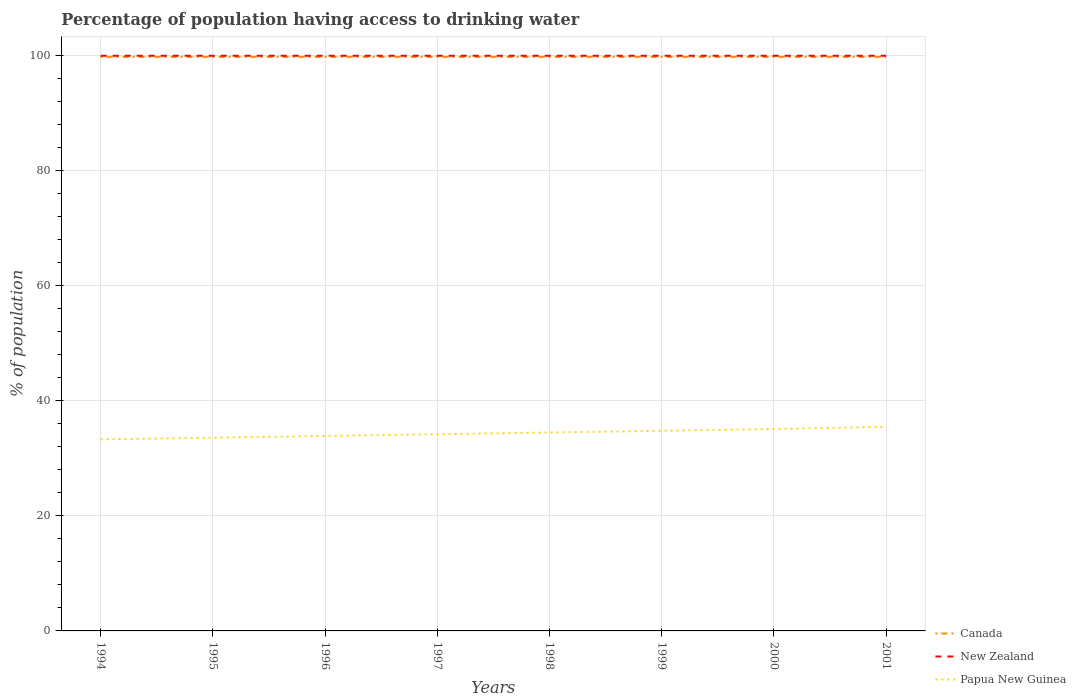How many different coloured lines are there?
Offer a terse response. 3. Is the number of lines equal to the number of legend labels?
Your answer should be compact. Yes. Across all years, what is the maximum percentage of population having access to drinking water in Canada?
Ensure brevity in your answer.  99.8. In which year was the percentage of population having access to drinking water in Canada maximum?
Your answer should be compact. 1994. What is the difference between the highest and the second highest percentage of population having access to drinking water in Papua New Guinea?
Make the answer very short. 2.2. What is the difference between the highest and the lowest percentage of population having access to drinking water in Canada?
Provide a succinct answer. 0. How many years are there in the graph?
Your answer should be compact. 8. Does the graph contain any zero values?
Keep it short and to the point. No. Does the graph contain grids?
Give a very brief answer. Yes. Where does the legend appear in the graph?
Your answer should be compact. Bottom right. How are the legend labels stacked?
Your answer should be compact. Vertical. What is the title of the graph?
Offer a terse response. Percentage of population having access to drinking water. What is the label or title of the X-axis?
Offer a terse response. Years. What is the label or title of the Y-axis?
Ensure brevity in your answer.  % of population. What is the % of population of Canada in 1994?
Offer a very short reply. 99.8. What is the % of population in New Zealand in 1994?
Your answer should be compact. 100. What is the % of population in Papua New Guinea in 1994?
Ensure brevity in your answer.  33.3. What is the % of population of Canada in 1995?
Provide a succinct answer. 99.8. What is the % of population of New Zealand in 1995?
Provide a short and direct response. 100. What is the % of population in Papua New Guinea in 1995?
Your response must be concise. 33.6. What is the % of population in Canada in 1996?
Offer a terse response. 99.8. What is the % of population of Papua New Guinea in 1996?
Offer a very short reply. 33.9. What is the % of population of Canada in 1997?
Provide a short and direct response. 99.8. What is the % of population of New Zealand in 1997?
Ensure brevity in your answer.  100. What is the % of population in Papua New Guinea in 1997?
Your answer should be very brief. 34.2. What is the % of population in Canada in 1998?
Your answer should be very brief. 99.8. What is the % of population in New Zealand in 1998?
Your answer should be very brief. 100. What is the % of population of Papua New Guinea in 1998?
Provide a short and direct response. 34.5. What is the % of population in Canada in 1999?
Your response must be concise. 99.8. What is the % of population in New Zealand in 1999?
Make the answer very short. 100. What is the % of population in Papua New Guinea in 1999?
Make the answer very short. 34.8. What is the % of population in Canada in 2000?
Ensure brevity in your answer.  99.8. What is the % of population in Papua New Guinea in 2000?
Provide a succinct answer. 35.1. What is the % of population in Canada in 2001?
Your answer should be compact. 99.8. What is the % of population in Papua New Guinea in 2001?
Your answer should be very brief. 35.5. Across all years, what is the maximum % of population of Canada?
Give a very brief answer. 99.8. Across all years, what is the maximum % of population of New Zealand?
Provide a short and direct response. 100. Across all years, what is the maximum % of population in Papua New Guinea?
Ensure brevity in your answer.  35.5. Across all years, what is the minimum % of population in Canada?
Your answer should be very brief. 99.8. Across all years, what is the minimum % of population in Papua New Guinea?
Your answer should be compact. 33.3. What is the total % of population of Canada in the graph?
Make the answer very short. 798.4. What is the total % of population of New Zealand in the graph?
Provide a succinct answer. 800. What is the total % of population in Papua New Guinea in the graph?
Your response must be concise. 274.9. What is the difference between the % of population of Canada in 1994 and that in 1995?
Provide a succinct answer. 0. What is the difference between the % of population in Canada in 1994 and that in 1996?
Ensure brevity in your answer.  0. What is the difference between the % of population in Canada in 1994 and that in 1997?
Ensure brevity in your answer.  0. What is the difference between the % of population in Papua New Guinea in 1994 and that in 1998?
Offer a very short reply. -1.2. What is the difference between the % of population in Canada in 1994 and that in 2000?
Offer a terse response. 0. What is the difference between the % of population of Papua New Guinea in 1994 and that in 2000?
Provide a succinct answer. -1.8. What is the difference between the % of population in Canada in 1994 and that in 2001?
Your answer should be very brief. 0. What is the difference between the % of population of New Zealand in 1994 and that in 2001?
Keep it short and to the point. 0. What is the difference between the % of population in Papua New Guinea in 1994 and that in 2001?
Offer a terse response. -2.2. What is the difference between the % of population in New Zealand in 1995 and that in 1997?
Provide a succinct answer. 0. What is the difference between the % of population of Papua New Guinea in 1995 and that in 1997?
Provide a succinct answer. -0.6. What is the difference between the % of population of Canada in 1995 and that in 1999?
Make the answer very short. 0. What is the difference between the % of population of Papua New Guinea in 1995 and that in 1999?
Provide a succinct answer. -1.2. What is the difference between the % of population in Canada in 1995 and that in 2000?
Your answer should be very brief. 0. What is the difference between the % of population in New Zealand in 1995 and that in 2000?
Offer a very short reply. 0. What is the difference between the % of population in Papua New Guinea in 1995 and that in 2000?
Your answer should be very brief. -1.5. What is the difference between the % of population of New Zealand in 1995 and that in 2001?
Your answer should be compact. 0. What is the difference between the % of population in Papua New Guinea in 1995 and that in 2001?
Offer a terse response. -1.9. What is the difference between the % of population of New Zealand in 1996 and that in 1997?
Make the answer very short. 0. What is the difference between the % of population of Papua New Guinea in 1996 and that in 1997?
Your answer should be compact. -0.3. What is the difference between the % of population of New Zealand in 1996 and that in 1998?
Offer a very short reply. 0. What is the difference between the % of population in Papua New Guinea in 1996 and that in 1998?
Your answer should be very brief. -0.6. What is the difference between the % of population in Canada in 1996 and that in 1999?
Provide a succinct answer. 0. What is the difference between the % of population of Canada in 1996 and that in 2000?
Give a very brief answer. 0. What is the difference between the % of population in New Zealand in 1996 and that in 2000?
Your answer should be compact. 0. What is the difference between the % of population in Canada in 1996 and that in 2001?
Offer a very short reply. 0. What is the difference between the % of population in New Zealand in 1996 and that in 2001?
Provide a succinct answer. 0. What is the difference between the % of population in Papua New Guinea in 1997 and that in 1998?
Your answer should be very brief. -0.3. What is the difference between the % of population in Canada in 1997 and that in 1999?
Provide a succinct answer. 0. What is the difference between the % of population in New Zealand in 1997 and that in 1999?
Your response must be concise. 0. What is the difference between the % of population of Papua New Guinea in 1997 and that in 1999?
Offer a very short reply. -0.6. What is the difference between the % of population in New Zealand in 1997 and that in 2000?
Make the answer very short. 0. What is the difference between the % of population in Papua New Guinea in 1997 and that in 2000?
Your answer should be very brief. -0.9. What is the difference between the % of population in Canada in 1998 and that in 1999?
Provide a short and direct response. 0. What is the difference between the % of population of Papua New Guinea in 1998 and that in 1999?
Make the answer very short. -0.3. What is the difference between the % of population of Canada in 1998 and that in 2000?
Your answer should be compact. 0. What is the difference between the % of population of Papua New Guinea in 1998 and that in 2000?
Give a very brief answer. -0.6. What is the difference between the % of population in Canada in 1998 and that in 2001?
Offer a very short reply. 0. What is the difference between the % of population in Papua New Guinea in 1999 and that in 2000?
Offer a terse response. -0.3. What is the difference between the % of population of New Zealand in 2000 and that in 2001?
Keep it short and to the point. 0. What is the difference between the % of population of Papua New Guinea in 2000 and that in 2001?
Make the answer very short. -0.4. What is the difference between the % of population of Canada in 1994 and the % of population of New Zealand in 1995?
Your response must be concise. -0.2. What is the difference between the % of population in Canada in 1994 and the % of population in Papua New Guinea in 1995?
Keep it short and to the point. 66.2. What is the difference between the % of population of New Zealand in 1994 and the % of population of Papua New Guinea in 1995?
Offer a very short reply. 66.4. What is the difference between the % of population in Canada in 1994 and the % of population in Papua New Guinea in 1996?
Make the answer very short. 65.9. What is the difference between the % of population in New Zealand in 1994 and the % of population in Papua New Guinea in 1996?
Provide a succinct answer. 66.1. What is the difference between the % of population of Canada in 1994 and the % of population of Papua New Guinea in 1997?
Your response must be concise. 65.6. What is the difference between the % of population in New Zealand in 1994 and the % of population in Papua New Guinea in 1997?
Your response must be concise. 65.8. What is the difference between the % of population of Canada in 1994 and the % of population of New Zealand in 1998?
Provide a succinct answer. -0.2. What is the difference between the % of population of Canada in 1994 and the % of population of Papua New Guinea in 1998?
Offer a terse response. 65.3. What is the difference between the % of population of New Zealand in 1994 and the % of population of Papua New Guinea in 1998?
Keep it short and to the point. 65.5. What is the difference between the % of population in Canada in 1994 and the % of population in New Zealand in 1999?
Provide a short and direct response. -0.2. What is the difference between the % of population in Canada in 1994 and the % of population in Papua New Guinea in 1999?
Provide a short and direct response. 65. What is the difference between the % of population of New Zealand in 1994 and the % of population of Papua New Guinea in 1999?
Provide a succinct answer. 65.2. What is the difference between the % of population of Canada in 1994 and the % of population of New Zealand in 2000?
Keep it short and to the point. -0.2. What is the difference between the % of population of Canada in 1994 and the % of population of Papua New Guinea in 2000?
Provide a short and direct response. 64.7. What is the difference between the % of population in New Zealand in 1994 and the % of population in Papua New Guinea in 2000?
Provide a succinct answer. 64.9. What is the difference between the % of population in Canada in 1994 and the % of population in Papua New Guinea in 2001?
Offer a very short reply. 64.3. What is the difference between the % of population of New Zealand in 1994 and the % of population of Papua New Guinea in 2001?
Offer a terse response. 64.5. What is the difference between the % of population of Canada in 1995 and the % of population of Papua New Guinea in 1996?
Provide a succinct answer. 65.9. What is the difference between the % of population in New Zealand in 1995 and the % of population in Papua New Guinea in 1996?
Offer a terse response. 66.1. What is the difference between the % of population in Canada in 1995 and the % of population in Papua New Guinea in 1997?
Your answer should be very brief. 65.6. What is the difference between the % of population of New Zealand in 1995 and the % of population of Papua New Guinea in 1997?
Provide a short and direct response. 65.8. What is the difference between the % of population in Canada in 1995 and the % of population in Papua New Guinea in 1998?
Your answer should be very brief. 65.3. What is the difference between the % of population of New Zealand in 1995 and the % of population of Papua New Guinea in 1998?
Offer a very short reply. 65.5. What is the difference between the % of population of Canada in 1995 and the % of population of Papua New Guinea in 1999?
Offer a terse response. 65. What is the difference between the % of population in New Zealand in 1995 and the % of population in Papua New Guinea in 1999?
Provide a short and direct response. 65.2. What is the difference between the % of population in Canada in 1995 and the % of population in New Zealand in 2000?
Provide a short and direct response. -0.2. What is the difference between the % of population of Canada in 1995 and the % of population of Papua New Guinea in 2000?
Your answer should be compact. 64.7. What is the difference between the % of population of New Zealand in 1995 and the % of population of Papua New Guinea in 2000?
Provide a short and direct response. 64.9. What is the difference between the % of population in Canada in 1995 and the % of population in New Zealand in 2001?
Your answer should be very brief. -0.2. What is the difference between the % of population in Canada in 1995 and the % of population in Papua New Guinea in 2001?
Offer a terse response. 64.3. What is the difference between the % of population of New Zealand in 1995 and the % of population of Papua New Guinea in 2001?
Give a very brief answer. 64.5. What is the difference between the % of population in Canada in 1996 and the % of population in Papua New Guinea in 1997?
Your answer should be compact. 65.6. What is the difference between the % of population of New Zealand in 1996 and the % of population of Papua New Guinea in 1997?
Provide a short and direct response. 65.8. What is the difference between the % of population of Canada in 1996 and the % of population of Papua New Guinea in 1998?
Provide a succinct answer. 65.3. What is the difference between the % of population of New Zealand in 1996 and the % of population of Papua New Guinea in 1998?
Provide a short and direct response. 65.5. What is the difference between the % of population of New Zealand in 1996 and the % of population of Papua New Guinea in 1999?
Provide a short and direct response. 65.2. What is the difference between the % of population of Canada in 1996 and the % of population of Papua New Guinea in 2000?
Give a very brief answer. 64.7. What is the difference between the % of population of New Zealand in 1996 and the % of population of Papua New Guinea in 2000?
Provide a succinct answer. 64.9. What is the difference between the % of population in Canada in 1996 and the % of population in Papua New Guinea in 2001?
Offer a terse response. 64.3. What is the difference between the % of population of New Zealand in 1996 and the % of population of Papua New Guinea in 2001?
Your response must be concise. 64.5. What is the difference between the % of population of Canada in 1997 and the % of population of New Zealand in 1998?
Your response must be concise. -0.2. What is the difference between the % of population in Canada in 1997 and the % of population in Papua New Guinea in 1998?
Your answer should be compact. 65.3. What is the difference between the % of population of New Zealand in 1997 and the % of population of Papua New Guinea in 1998?
Your response must be concise. 65.5. What is the difference between the % of population of Canada in 1997 and the % of population of New Zealand in 1999?
Keep it short and to the point. -0.2. What is the difference between the % of population in Canada in 1997 and the % of population in Papua New Guinea in 1999?
Your response must be concise. 65. What is the difference between the % of population in New Zealand in 1997 and the % of population in Papua New Guinea in 1999?
Keep it short and to the point. 65.2. What is the difference between the % of population in Canada in 1997 and the % of population in Papua New Guinea in 2000?
Make the answer very short. 64.7. What is the difference between the % of population of New Zealand in 1997 and the % of population of Papua New Guinea in 2000?
Keep it short and to the point. 64.9. What is the difference between the % of population in Canada in 1997 and the % of population in Papua New Guinea in 2001?
Offer a terse response. 64.3. What is the difference between the % of population of New Zealand in 1997 and the % of population of Papua New Guinea in 2001?
Ensure brevity in your answer.  64.5. What is the difference between the % of population in Canada in 1998 and the % of population in New Zealand in 1999?
Offer a very short reply. -0.2. What is the difference between the % of population of Canada in 1998 and the % of population of Papua New Guinea in 1999?
Offer a very short reply. 65. What is the difference between the % of population of New Zealand in 1998 and the % of population of Papua New Guinea in 1999?
Ensure brevity in your answer.  65.2. What is the difference between the % of population of Canada in 1998 and the % of population of New Zealand in 2000?
Ensure brevity in your answer.  -0.2. What is the difference between the % of population in Canada in 1998 and the % of population in Papua New Guinea in 2000?
Provide a short and direct response. 64.7. What is the difference between the % of population in New Zealand in 1998 and the % of population in Papua New Guinea in 2000?
Offer a terse response. 64.9. What is the difference between the % of population of Canada in 1998 and the % of population of Papua New Guinea in 2001?
Give a very brief answer. 64.3. What is the difference between the % of population in New Zealand in 1998 and the % of population in Papua New Guinea in 2001?
Keep it short and to the point. 64.5. What is the difference between the % of population of Canada in 1999 and the % of population of New Zealand in 2000?
Make the answer very short. -0.2. What is the difference between the % of population of Canada in 1999 and the % of population of Papua New Guinea in 2000?
Your answer should be very brief. 64.7. What is the difference between the % of population of New Zealand in 1999 and the % of population of Papua New Guinea in 2000?
Make the answer very short. 64.9. What is the difference between the % of population of Canada in 1999 and the % of population of New Zealand in 2001?
Give a very brief answer. -0.2. What is the difference between the % of population in Canada in 1999 and the % of population in Papua New Guinea in 2001?
Offer a very short reply. 64.3. What is the difference between the % of population in New Zealand in 1999 and the % of population in Papua New Guinea in 2001?
Your response must be concise. 64.5. What is the difference between the % of population in Canada in 2000 and the % of population in New Zealand in 2001?
Your answer should be compact. -0.2. What is the difference between the % of population in Canada in 2000 and the % of population in Papua New Guinea in 2001?
Make the answer very short. 64.3. What is the difference between the % of population in New Zealand in 2000 and the % of population in Papua New Guinea in 2001?
Ensure brevity in your answer.  64.5. What is the average % of population of Canada per year?
Your response must be concise. 99.8. What is the average % of population of New Zealand per year?
Your answer should be very brief. 100. What is the average % of population of Papua New Guinea per year?
Your answer should be compact. 34.36. In the year 1994, what is the difference between the % of population in Canada and % of population in New Zealand?
Your response must be concise. -0.2. In the year 1994, what is the difference between the % of population of Canada and % of population of Papua New Guinea?
Your answer should be compact. 66.5. In the year 1994, what is the difference between the % of population in New Zealand and % of population in Papua New Guinea?
Provide a short and direct response. 66.7. In the year 1995, what is the difference between the % of population of Canada and % of population of Papua New Guinea?
Offer a very short reply. 66.2. In the year 1995, what is the difference between the % of population of New Zealand and % of population of Papua New Guinea?
Your answer should be compact. 66.4. In the year 1996, what is the difference between the % of population of Canada and % of population of New Zealand?
Give a very brief answer. -0.2. In the year 1996, what is the difference between the % of population of Canada and % of population of Papua New Guinea?
Make the answer very short. 65.9. In the year 1996, what is the difference between the % of population of New Zealand and % of population of Papua New Guinea?
Your response must be concise. 66.1. In the year 1997, what is the difference between the % of population of Canada and % of population of New Zealand?
Provide a short and direct response. -0.2. In the year 1997, what is the difference between the % of population in Canada and % of population in Papua New Guinea?
Your answer should be compact. 65.6. In the year 1997, what is the difference between the % of population in New Zealand and % of population in Papua New Guinea?
Your answer should be compact. 65.8. In the year 1998, what is the difference between the % of population in Canada and % of population in New Zealand?
Provide a short and direct response. -0.2. In the year 1998, what is the difference between the % of population in Canada and % of population in Papua New Guinea?
Ensure brevity in your answer.  65.3. In the year 1998, what is the difference between the % of population in New Zealand and % of population in Papua New Guinea?
Provide a short and direct response. 65.5. In the year 1999, what is the difference between the % of population of Canada and % of population of New Zealand?
Give a very brief answer. -0.2. In the year 1999, what is the difference between the % of population of Canada and % of population of Papua New Guinea?
Your answer should be compact. 65. In the year 1999, what is the difference between the % of population in New Zealand and % of population in Papua New Guinea?
Your answer should be very brief. 65.2. In the year 2000, what is the difference between the % of population of Canada and % of population of New Zealand?
Offer a terse response. -0.2. In the year 2000, what is the difference between the % of population in Canada and % of population in Papua New Guinea?
Ensure brevity in your answer.  64.7. In the year 2000, what is the difference between the % of population of New Zealand and % of population of Papua New Guinea?
Give a very brief answer. 64.9. In the year 2001, what is the difference between the % of population of Canada and % of population of Papua New Guinea?
Ensure brevity in your answer.  64.3. In the year 2001, what is the difference between the % of population of New Zealand and % of population of Papua New Guinea?
Provide a succinct answer. 64.5. What is the ratio of the % of population in New Zealand in 1994 to that in 1995?
Provide a succinct answer. 1. What is the ratio of the % of population of Papua New Guinea in 1994 to that in 1995?
Make the answer very short. 0.99. What is the ratio of the % of population of Canada in 1994 to that in 1996?
Provide a succinct answer. 1. What is the ratio of the % of population of Papua New Guinea in 1994 to that in 1996?
Make the answer very short. 0.98. What is the ratio of the % of population in Canada in 1994 to that in 1997?
Your answer should be very brief. 1. What is the ratio of the % of population in Papua New Guinea in 1994 to that in 1997?
Your answer should be compact. 0.97. What is the ratio of the % of population in Canada in 1994 to that in 1998?
Your answer should be very brief. 1. What is the ratio of the % of population in New Zealand in 1994 to that in 1998?
Offer a very short reply. 1. What is the ratio of the % of population in Papua New Guinea in 1994 to that in 1998?
Offer a very short reply. 0.97. What is the ratio of the % of population of Papua New Guinea in 1994 to that in 1999?
Make the answer very short. 0.96. What is the ratio of the % of population of Canada in 1994 to that in 2000?
Ensure brevity in your answer.  1. What is the ratio of the % of population of New Zealand in 1994 to that in 2000?
Provide a succinct answer. 1. What is the ratio of the % of population of Papua New Guinea in 1994 to that in 2000?
Offer a very short reply. 0.95. What is the ratio of the % of population of Canada in 1994 to that in 2001?
Your answer should be compact. 1. What is the ratio of the % of population of Papua New Guinea in 1994 to that in 2001?
Make the answer very short. 0.94. What is the ratio of the % of population of Canada in 1995 to that in 1996?
Your answer should be compact. 1. What is the ratio of the % of population of Papua New Guinea in 1995 to that in 1996?
Keep it short and to the point. 0.99. What is the ratio of the % of population of Papua New Guinea in 1995 to that in 1997?
Ensure brevity in your answer.  0.98. What is the ratio of the % of population in Canada in 1995 to that in 1998?
Provide a short and direct response. 1. What is the ratio of the % of population in New Zealand in 1995 to that in 1998?
Give a very brief answer. 1. What is the ratio of the % of population in Papua New Guinea in 1995 to that in 1998?
Offer a very short reply. 0.97. What is the ratio of the % of population in New Zealand in 1995 to that in 1999?
Ensure brevity in your answer.  1. What is the ratio of the % of population in Papua New Guinea in 1995 to that in 1999?
Your response must be concise. 0.97. What is the ratio of the % of population in Canada in 1995 to that in 2000?
Your answer should be very brief. 1. What is the ratio of the % of population in Papua New Guinea in 1995 to that in 2000?
Give a very brief answer. 0.96. What is the ratio of the % of population in Papua New Guinea in 1995 to that in 2001?
Provide a succinct answer. 0.95. What is the ratio of the % of population in New Zealand in 1996 to that in 1997?
Ensure brevity in your answer.  1. What is the ratio of the % of population in Papua New Guinea in 1996 to that in 1997?
Your response must be concise. 0.99. What is the ratio of the % of population of New Zealand in 1996 to that in 1998?
Your answer should be very brief. 1. What is the ratio of the % of population in Papua New Guinea in 1996 to that in 1998?
Keep it short and to the point. 0.98. What is the ratio of the % of population of Canada in 1996 to that in 1999?
Offer a terse response. 1. What is the ratio of the % of population in New Zealand in 1996 to that in 1999?
Provide a short and direct response. 1. What is the ratio of the % of population of Papua New Guinea in 1996 to that in 1999?
Keep it short and to the point. 0.97. What is the ratio of the % of population in Canada in 1996 to that in 2000?
Your answer should be very brief. 1. What is the ratio of the % of population in Papua New Guinea in 1996 to that in 2000?
Offer a very short reply. 0.97. What is the ratio of the % of population of Canada in 1996 to that in 2001?
Provide a succinct answer. 1. What is the ratio of the % of population of Papua New Guinea in 1996 to that in 2001?
Make the answer very short. 0.95. What is the ratio of the % of population of New Zealand in 1997 to that in 1998?
Your response must be concise. 1. What is the ratio of the % of population in Canada in 1997 to that in 1999?
Your answer should be compact. 1. What is the ratio of the % of population of Papua New Guinea in 1997 to that in 1999?
Offer a very short reply. 0.98. What is the ratio of the % of population in Papua New Guinea in 1997 to that in 2000?
Keep it short and to the point. 0.97. What is the ratio of the % of population in Canada in 1997 to that in 2001?
Offer a very short reply. 1. What is the ratio of the % of population in New Zealand in 1997 to that in 2001?
Offer a terse response. 1. What is the ratio of the % of population in Papua New Guinea in 1997 to that in 2001?
Keep it short and to the point. 0.96. What is the ratio of the % of population of New Zealand in 1998 to that in 1999?
Your answer should be very brief. 1. What is the ratio of the % of population in New Zealand in 1998 to that in 2000?
Offer a terse response. 1. What is the ratio of the % of population of Papua New Guinea in 1998 to that in 2000?
Ensure brevity in your answer.  0.98. What is the ratio of the % of population in Canada in 1998 to that in 2001?
Your answer should be compact. 1. What is the ratio of the % of population of Papua New Guinea in 1998 to that in 2001?
Provide a succinct answer. 0.97. What is the ratio of the % of population of Canada in 1999 to that in 2000?
Provide a short and direct response. 1. What is the ratio of the % of population of New Zealand in 1999 to that in 2000?
Your response must be concise. 1. What is the ratio of the % of population of Papua New Guinea in 1999 to that in 2001?
Your answer should be very brief. 0.98. What is the ratio of the % of population in New Zealand in 2000 to that in 2001?
Offer a terse response. 1. What is the ratio of the % of population of Papua New Guinea in 2000 to that in 2001?
Your answer should be compact. 0.99. What is the difference between the highest and the second highest % of population of Canada?
Provide a short and direct response. 0. What is the difference between the highest and the lowest % of population of New Zealand?
Ensure brevity in your answer.  0. What is the difference between the highest and the lowest % of population of Papua New Guinea?
Offer a very short reply. 2.2. 